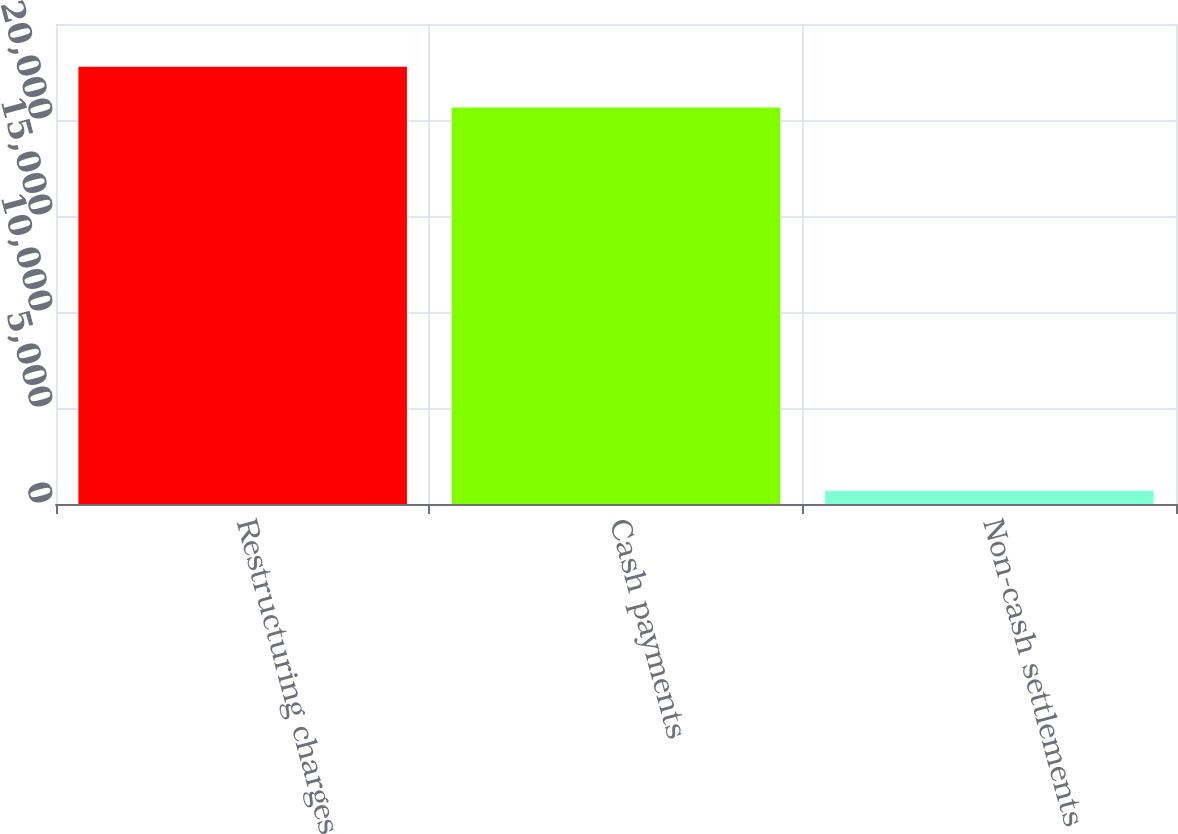<chart> <loc_0><loc_0><loc_500><loc_500><bar_chart><fcel>Restructuring charges<fcel>Cash payments<fcel>Non-cash settlements<nl><fcel>22778.8<fcel>20646<fcel>695<nl></chart> 